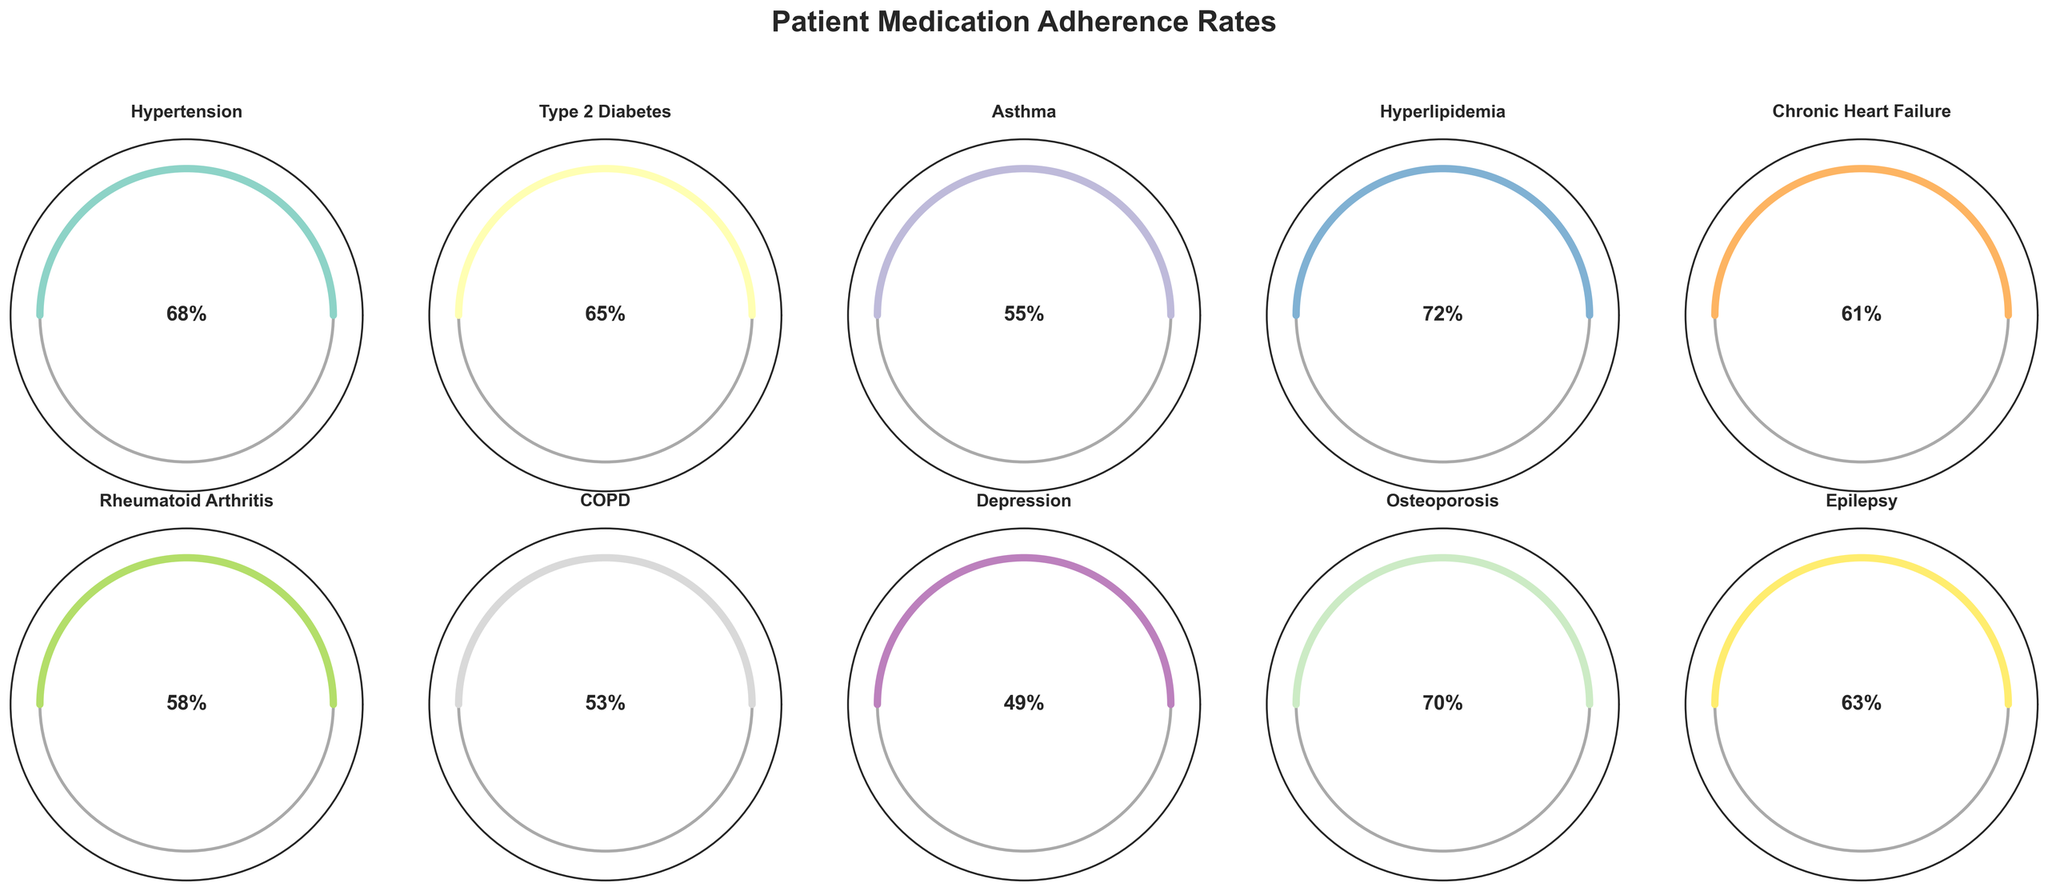Which condition shows the highest medication adherence rate? To find the highest adherence rate, we check the adherence rates for each condition listed and look for the maximum value. The highest adherence rate is for Hyperlipidemia which is 72%.
Answer: Hyperlipidemia What is the adherence rate for patients with Type 2 Diabetes? We look at the specific gauge corresponding to Type 2 Diabetes and identify the adherence rate in percentage. The figure shows this value as 65%.
Answer: 65% What is the average medication adherence rate of all conditions? Summing up all adherence rates (68 + 65 + 55 + 72 + 61 + 58 + 53 + 49 + 70 + 63) gives 614. Dividing by the number of conditions (10) yields an average adherence rate of 61.4%.
Answer: 61.4% Which condition has the lowest medication adherence rate? By comparing all adherence rates, we find that Depression has the lowest adherence rate of 49%.
Answer: Depression How many conditions have an adherence rate of at least 60%? We count the conditions with adherence rates of 60% and above: Hypertension (68%), Type 2 Diabetes (65%), Hyperlipidemia (72%), Chronic Heart Failure (61%), Osteoporosis (70%), and Epilepsy (63%). There are 6 such conditions.
Answer: 6 What is the difference in adherence rates between Hypertension and COPD? The adherence rate for Hypertension is 68%, while for COPD it is 53%. The difference is 68% - 53% = 15%.
Answer: 15% What is the median medication adherence rate of these conditions? To find the median, we first list and sort the rates (49, 53, 55, 58, 61, 63, 65, 68, 70, 72). With 10 conditions, the median is the average of the 5th and 6th values: (61 + 63) / 2 = 62%.
Answer: 62% Which condition has an adherence rate that is closest to the overall average? The overall average adherence rate is 61.4%. The rates closest to this value are Chronic Heart Failure (61%) and Epilepsy (63%). Chronic Heart Failure is closer.
Answer: Chronic Heart Failure How does the adherence rate of Epilepsy compare with that of Osteoporosis? The adherence rate for Epilepsy is 63%, while for Osteoporosis it is 70%. Epilepsy has a lower adherence rate than Osteoporosis by 7%.
Answer: Epilepsy is 7% lower than Osteoporosis What is the combined average adherence rate for the three conditions with the highest adherence rates? The highest rates are Hyperlipidemia (72%), Osteoporosis (70%), and Hypertension (68%). Summing these (72 + 70 + 68) gives 210. Dividing by 3, the average is 70%.
Answer: 70% 